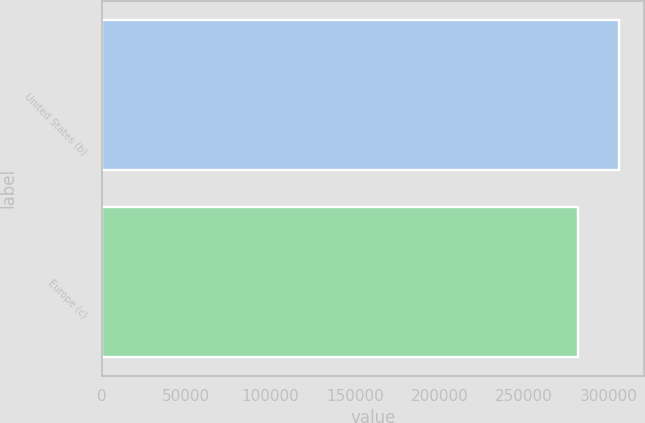Convert chart to OTSL. <chart><loc_0><loc_0><loc_500><loc_500><bar_chart><fcel>United States (b)<fcel>Europe (c)<nl><fcel>305852<fcel>281844<nl></chart> 